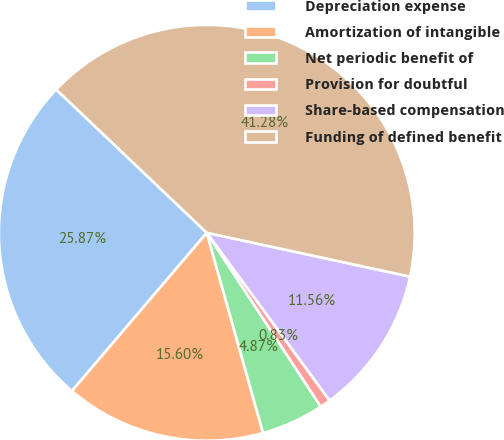Convert chart to OTSL. <chart><loc_0><loc_0><loc_500><loc_500><pie_chart><fcel>Depreciation expense<fcel>Amortization of intangible<fcel>Net periodic benefit of<fcel>Provision for doubtful<fcel>Share-based compensation<fcel>Funding of defined benefit<nl><fcel>25.87%<fcel>15.6%<fcel>4.87%<fcel>0.83%<fcel>11.56%<fcel>41.28%<nl></chart> 